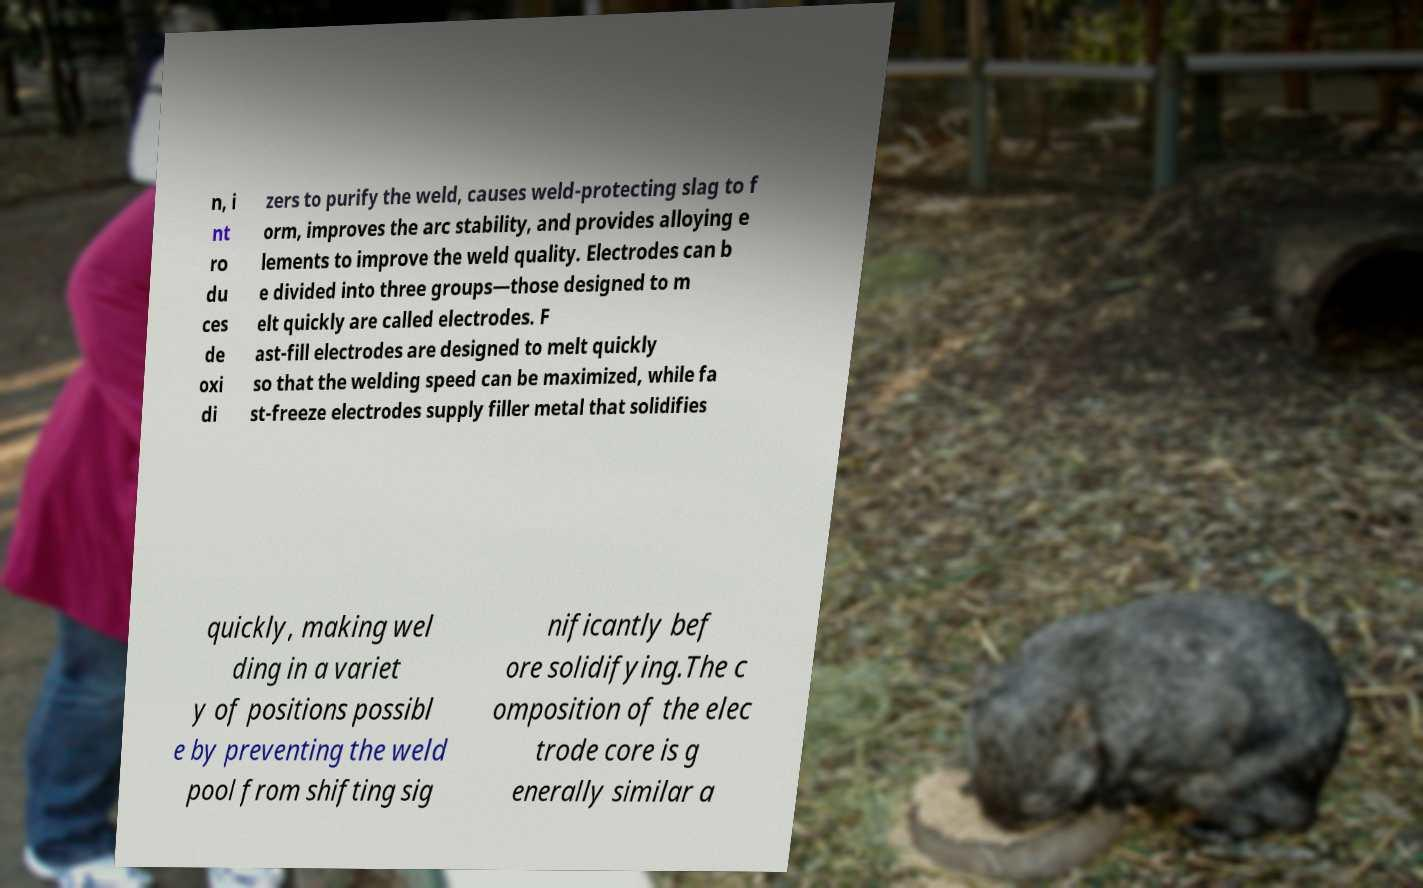What messages or text are displayed in this image? I need them in a readable, typed format. n, i nt ro du ces de oxi di zers to purify the weld, causes weld-protecting slag to f orm, improves the arc stability, and provides alloying e lements to improve the weld quality. Electrodes can b e divided into three groups—those designed to m elt quickly are called electrodes. F ast-fill electrodes are designed to melt quickly so that the welding speed can be maximized, while fa st-freeze electrodes supply filler metal that solidifies quickly, making wel ding in a variet y of positions possibl e by preventing the weld pool from shifting sig nificantly bef ore solidifying.The c omposition of the elec trode core is g enerally similar a 